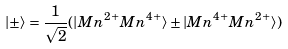<formula> <loc_0><loc_0><loc_500><loc_500>| \pm \rangle = \frac { 1 } { \sqrt { 2 } } ( | M n ^ { 2 + } M n ^ { 4 + } \rangle \pm | M n ^ { 4 + } M n ^ { 2 + } \rangle )</formula> 